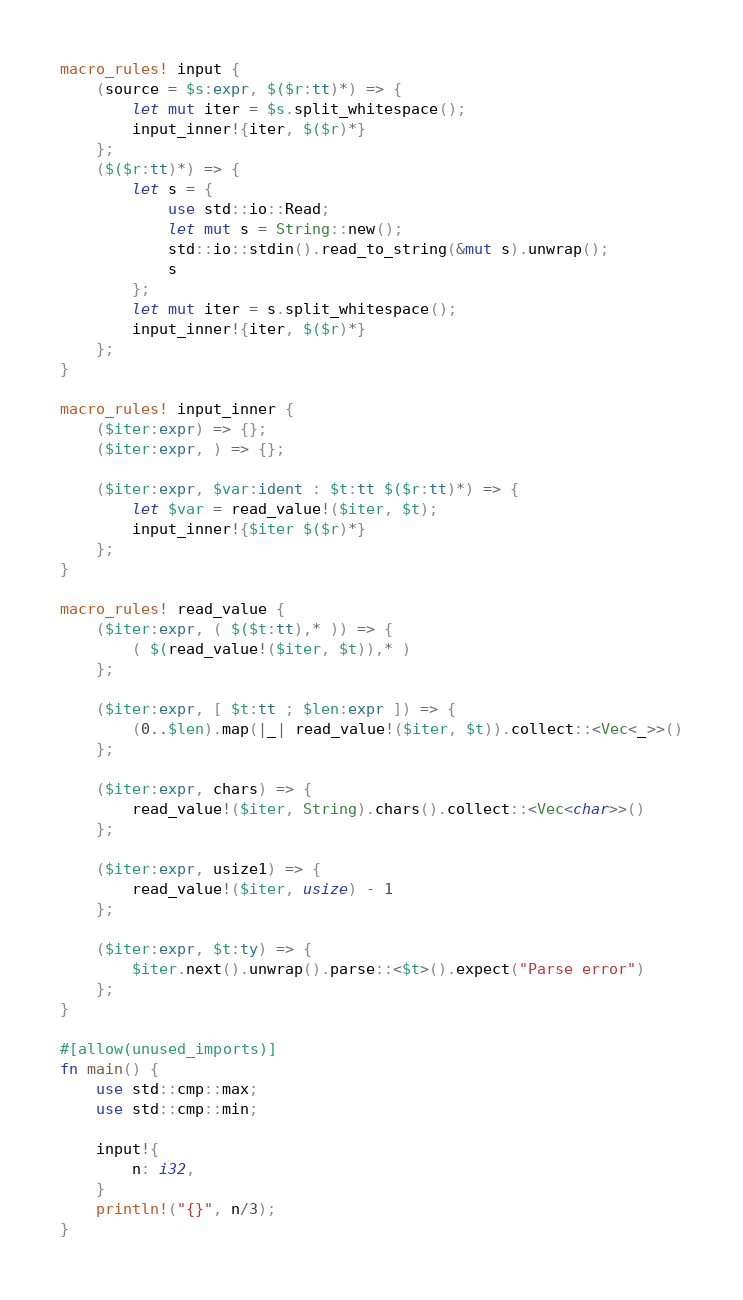Convert code to text. <code><loc_0><loc_0><loc_500><loc_500><_Rust_>macro_rules! input {
    (source = $s:expr, $($r:tt)*) => {
        let mut iter = $s.split_whitespace();
        input_inner!{iter, $($r)*}
    };
    ($($r:tt)*) => {
        let s = {
            use std::io::Read;
            let mut s = String::new();
            std::io::stdin().read_to_string(&mut s).unwrap();
            s
        };
        let mut iter = s.split_whitespace();
        input_inner!{iter, $($r)*}
    };
}

macro_rules! input_inner {
    ($iter:expr) => {};
    ($iter:expr, ) => {};

    ($iter:expr, $var:ident : $t:tt $($r:tt)*) => {
        let $var = read_value!($iter, $t);
        input_inner!{$iter $($r)*}
    };
}

macro_rules! read_value {
    ($iter:expr, ( $($t:tt),* )) => {
        ( $(read_value!($iter, $t)),* )
    };

    ($iter:expr, [ $t:tt ; $len:expr ]) => {
        (0..$len).map(|_| read_value!($iter, $t)).collect::<Vec<_>>()
    };

    ($iter:expr, chars) => {
        read_value!($iter, String).chars().collect::<Vec<char>>()
    };

    ($iter:expr, usize1) => {
        read_value!($iter, usize) - 1
    };

    ($iter:expr, $t:ty) => {
        $iter.next().unwrap().parse::<$t>().expect("Parse error")
    };
}

#[allow(unused_imports)]
fn main() {
    use std::cmp::max;
    use std::cmp::min;

    input!{
        n: i32,
    }
    println!("{}", n/3);
}
</code> 